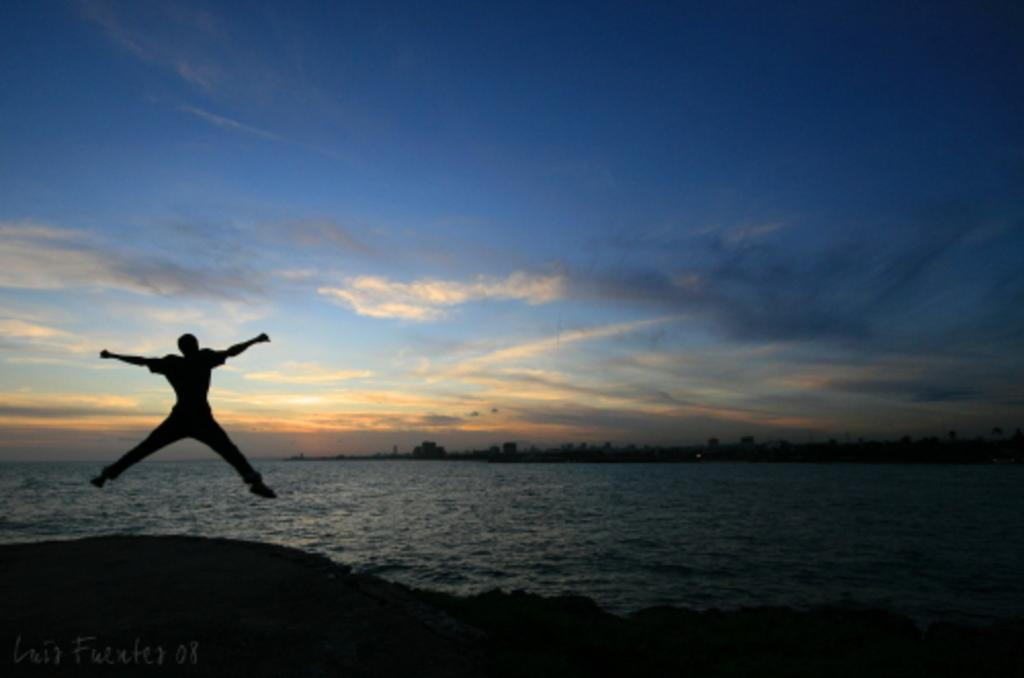Could you give a brief overview of what you see in this image? In this image, I can see a person jumping. These are the water. In the background, I can see the buildings. These are the clouds in the sky. At the bottom of the image, I can see the watermark. 